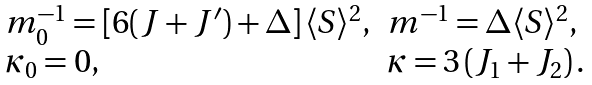<formula> <loc_0><loc_0><loc_500><loc_500>\begin{array} { l l } m _ { 0 } ^ { - 1 } = \left [ 6 ( J + J ^ { \prime } ) + \Delta \right ] \langle S \rangle ^ { 2 } , & m ^ { - 1 } = \Delta \langle S \rangle ^ { 2 } , \\ \kappa _ { 0 } = 0 , & \kappa = 3 \left ( J _ { 1 } + J _ { 2 } \right ) . \end{array}</formula> 